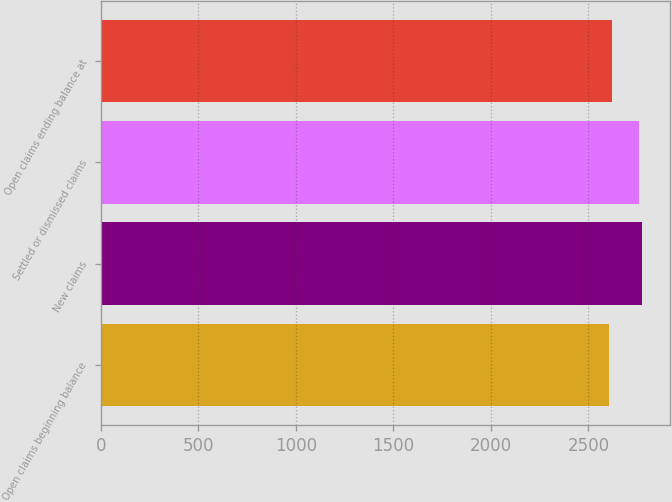<chart> <loc_0><loc_0><loc_500><loc_500><bar_chart><fcel>Open claims beginning balance<fcel>New claims<fcel>Settled or dismissed claims<fcel>Open claims ending balance at<nl><fcel>2605<fcel>2776.8<fcel>2760<fcel>2621.8<nl></chart> 